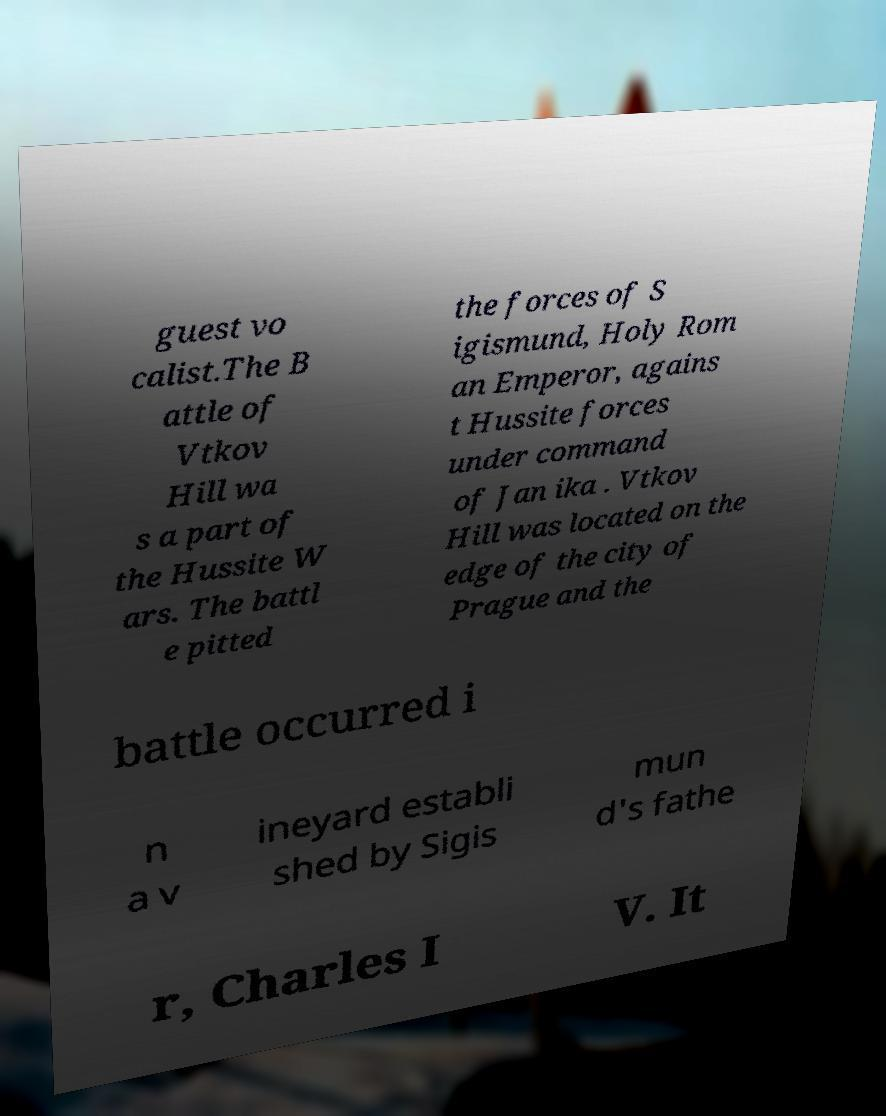Please identify and transcribe the text found in this image. guest vo calist.The B attle of Vtkov Hill wa s a part of the Hussite W ars. The battl e pitted the forces of S igismund, Holy Rom an Emperor, agains t Hussite forces under command of Jan ika . Vtkov Hill was located on the edge of the city of Prague and the battle occurred i n a v ineyard establi shed by Sigis mun d's fathe r, Charles I V. It 